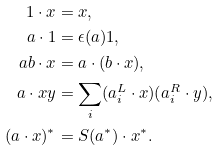Convert formula to latex. <formula><loc_0><loc_0><loc_500><loc_500>1 \cdot x & = x , \\ a \cdot 1 & = \epsilon ( a ) 1 , \\ a b \cdot x & = a \cdot ( b \cdot x ) , \\ a \cdot x y & = \sum _ { i } ( a _ { i } ^ { L } \cdot x ) ( a _ { i } ^ { R } \cdot y ) , \\ ( a \cdot x ) ^ { * } & = S ( a ^ { * } ) \cdot x ^ { * } .</formula> 